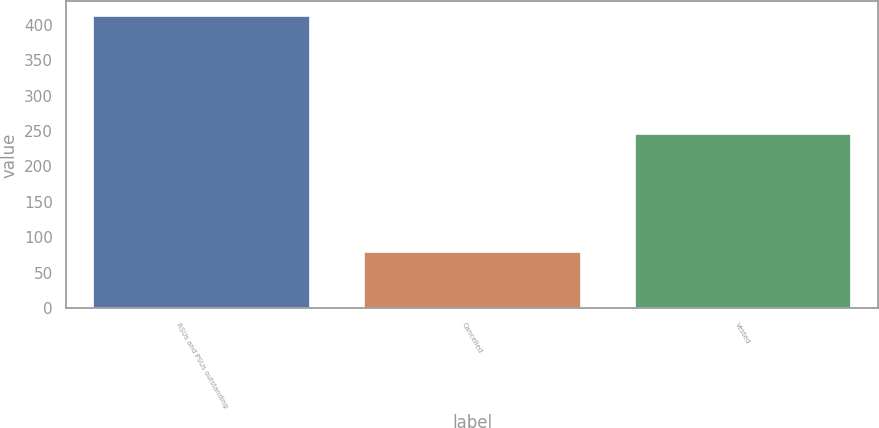Convert chart. <chart><loc_0><loc_0><loc_500><loc_500><bar_chart><fcel>RSUs and PSUs outstanding<fcel>Cancelled<fcel>Vested<nl><fcel>412<fcel>80<fcel>246<nl></chart> 